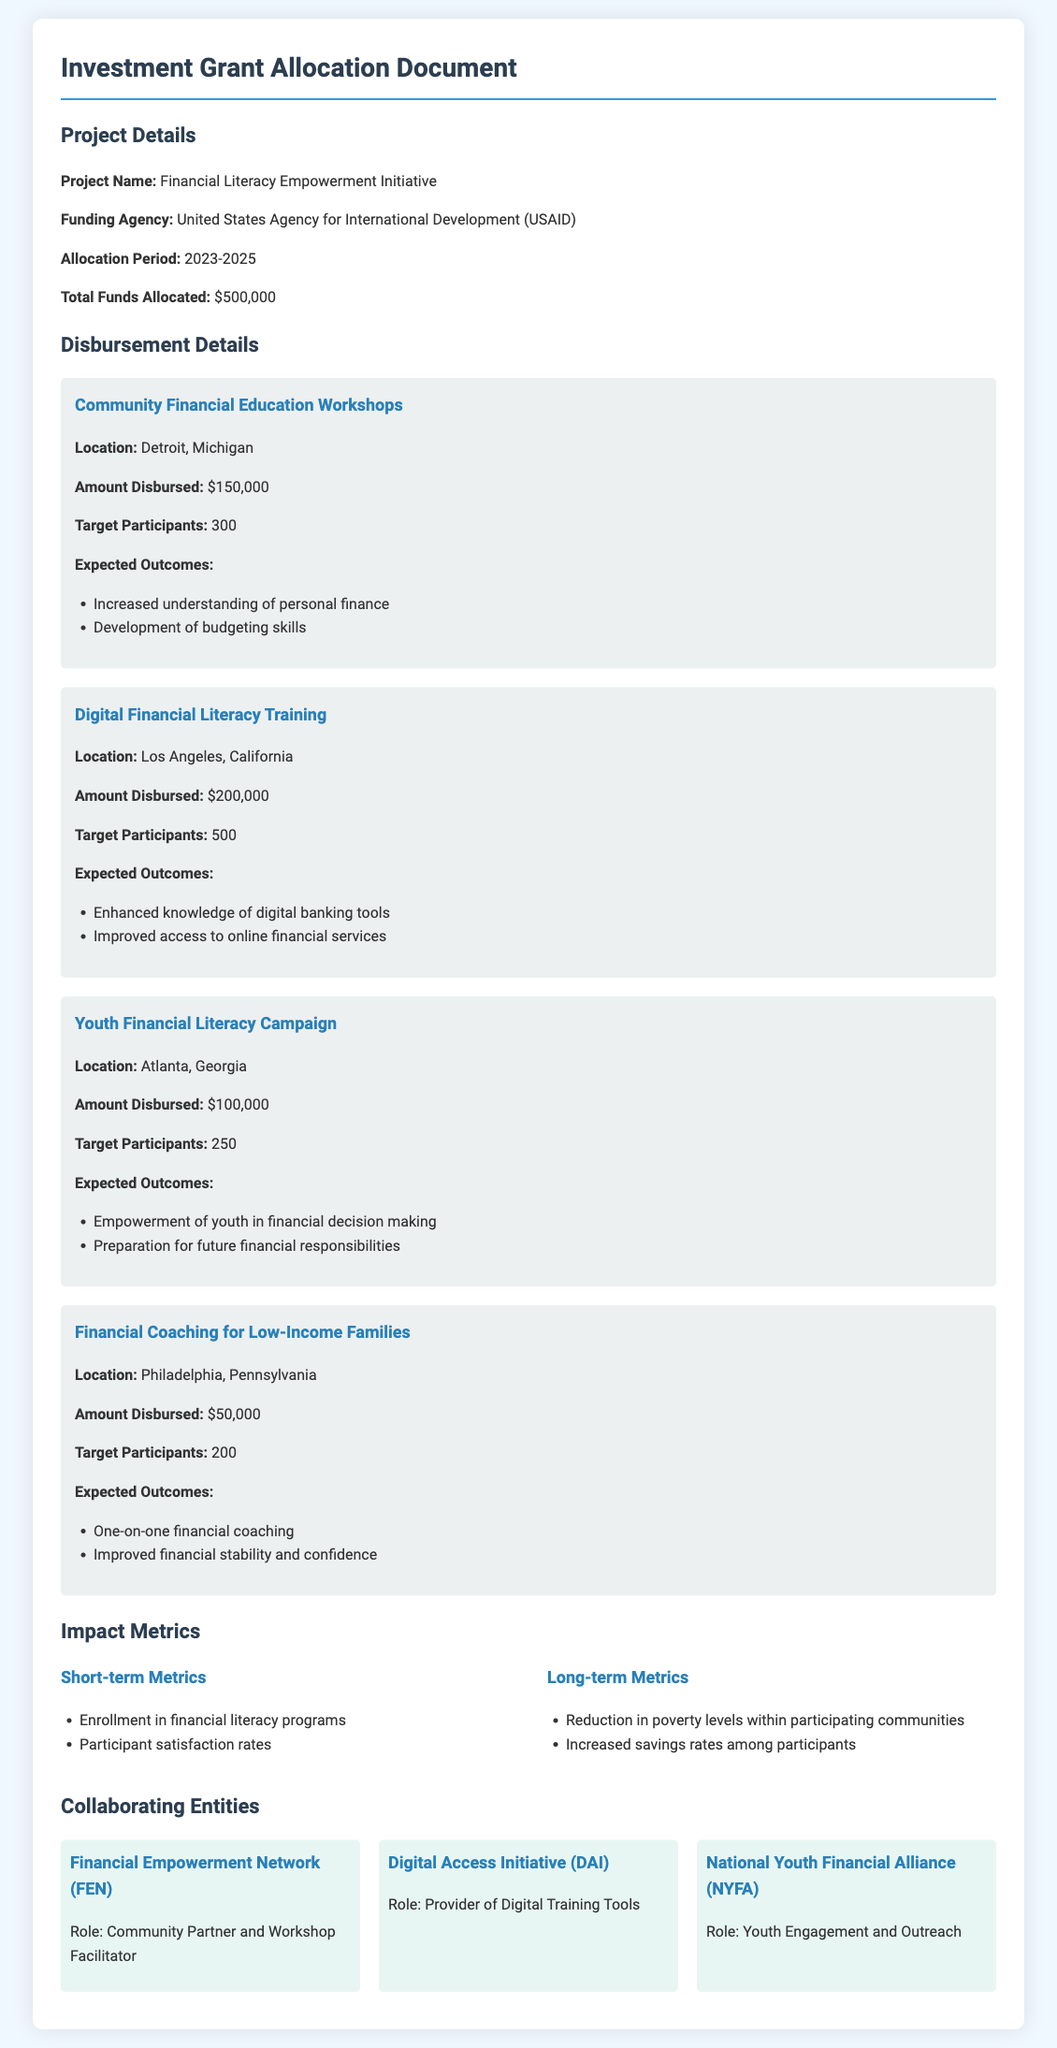What is the project name? The project name is stated in the document as "Financial Literacy Empowerment Initiative."
Answer: Financial Literacy Empowerment Initiative Who is the funding agency? The funding agency is mentioned as "United States Agency for International Development (USAID)."
Answer: United States Agency for International Development (USAID) How much total funds were allocated? The total funds allocated figure is clearly indicated as "$500,000."
Answer: $500,000 What is the location of the Digital Financial Literacy Training? The document specifies that the location is "Los Angeles, California."
Answer: Los Angeles, California How many participants are targeted in the Community Financial Education Workshops? The document states the target participants for this program as "300."
Answer: 300 What is one expected outcome of the Youth Financial Literacy Campaign? The document lists expected outcomes, one of which is "Empowerment of youth in financial decision making."
Answer: Empowerment of youth in financial decision making What are the short-term metrics mentioned in the document? The document summarizes the short-term metrics to include "Enrollment in financial literacy programs" and "Participant satisfaction rates."
Answer: Enrollment in financial literacy programs, Participant satisfaction rates Which collaborator is responsible for Youth Engagement and Outreach? The document identifies "National Youth Financial Alliance (NYFA)" as the entity responsible for this role.
Answer: National Youth Financial Alliance (NYFA) What is the amount disbursed for Financial Coaching for Low-Income Families? The document states the amount disbursed for this program is "$50,000."
Answer: $50,000 